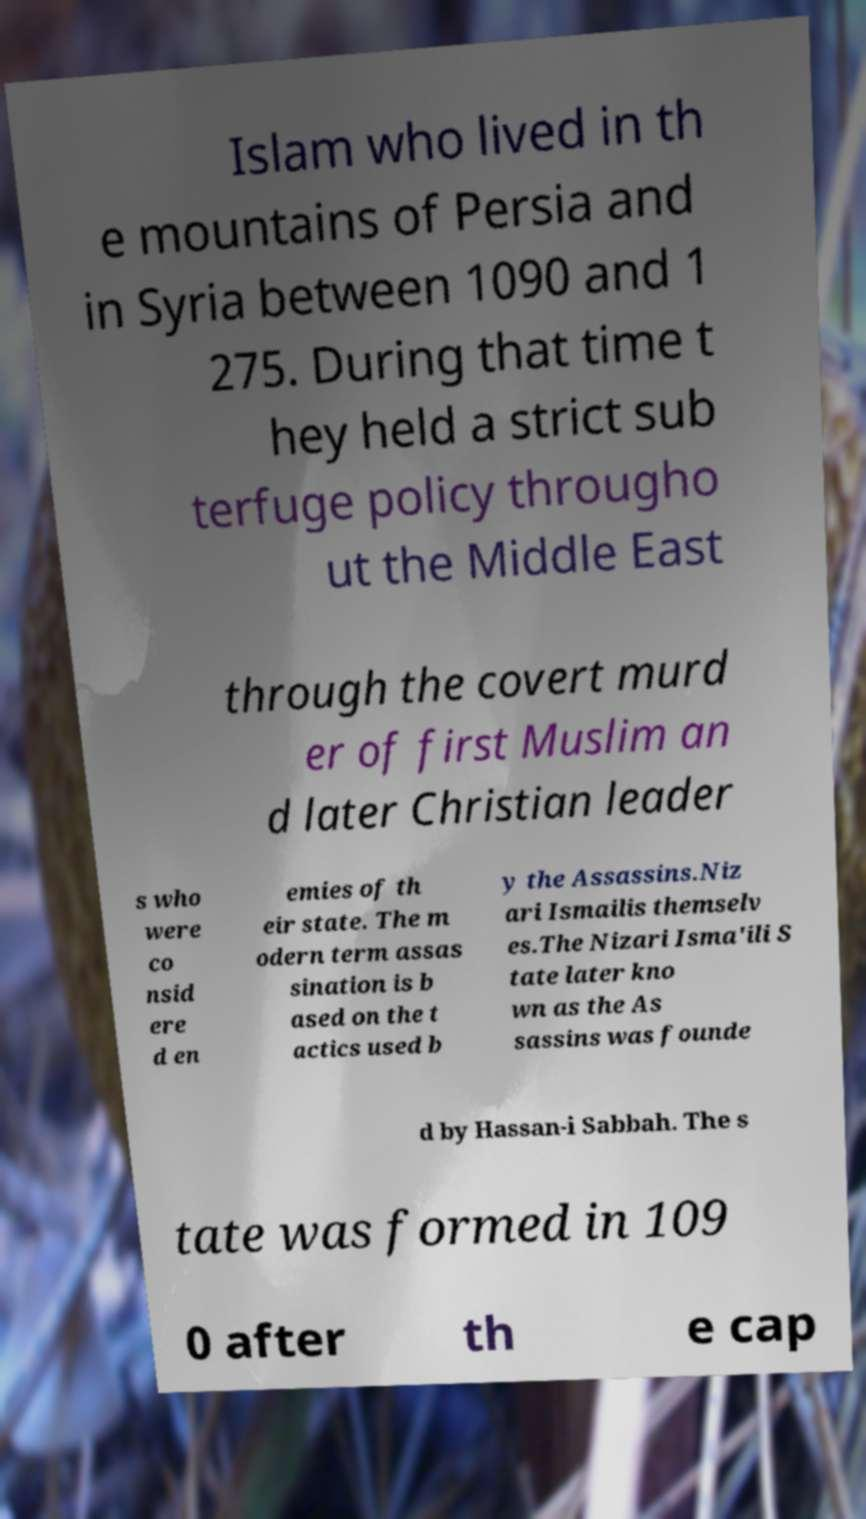For documentation purposes, I need the text within this image transcribed. Could you provide that? Islam who lived in th e mountains of Persia and in Syria between 1090 and 1 275. During that time t hey held a strict sub terfuge policy througho ut the Middle East through the covert murd er of first Muslim an d later Christian leader s who were co nsid ere d en emies of th eir state. The m odern term assas sination is b ased on the t actics used b y the Assassins.Niz ari Ismailis themselv es.The Nizari Isma'ili S tate later kno wn as the As sassins was founde d by Hassan-i Sabbah. The s tate was formed in 109 0 after th e cap 